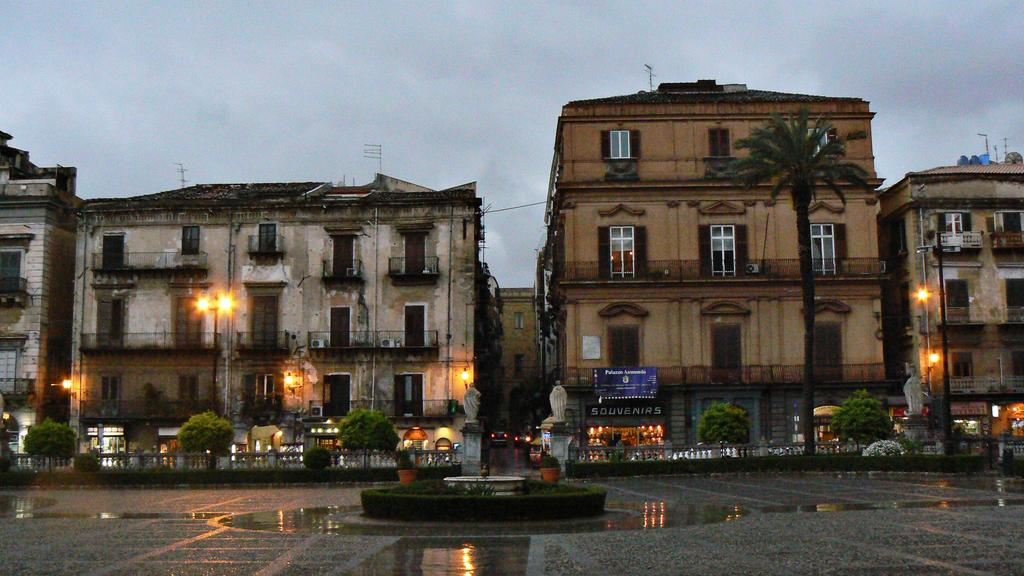What type of structures can be seen in the image? There are buildings in the image. What type of lighting is present in the image? Pole lights are present in the image. What type of vegetation is visible in the image? There are trees in the image. What is the condition of the ground in the image? There is water visible on the ground in the image. What is the weather like in the image? The sky is cloudy in the image. What type of signage is present in the image? There are name boards in the image. Can you see a bag floating in the water in the image? There is no bag visible in the water in the image. Is there a boat navigating through the water in the image? There is no boat present in the image. 